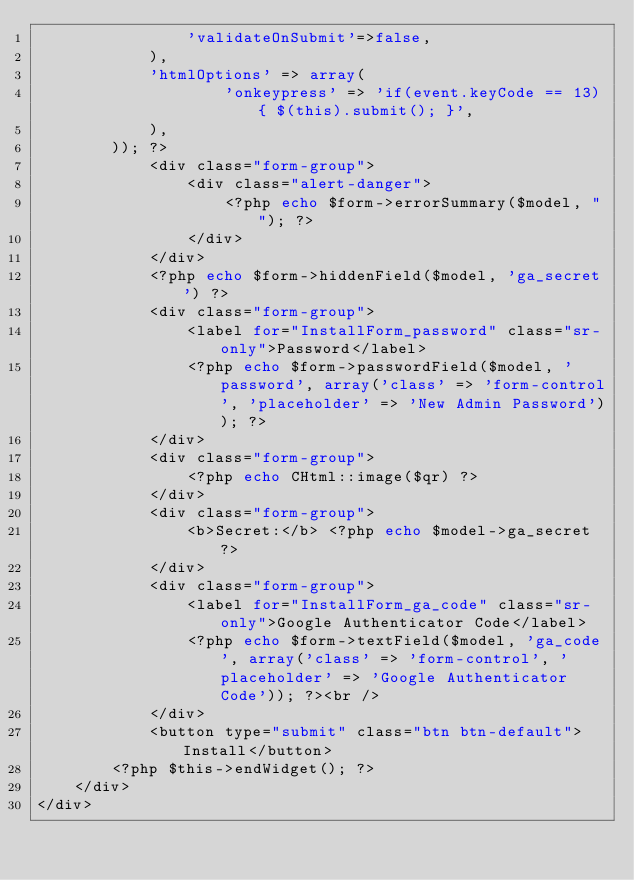Convert code to text. <code><loc_0><loc_0><loc_500><loc_500><_PHP_>				'validateOnSubmit'=>false,
			),
			'htmlOptions' => array(
					'onkeypress' => 'if(event.keyCode == 13){ $(this).submit(); }',
			),
		)); ?>
			<div class="form-group">
				<div class="alert-danger">
					<?php echo $form->errorSummary($model, ""); ?>
				</div>
			</div>
			<?php echo $form->hiddenField($model, 'ga_secret') ?>
			<div class="form-group">
				<label for="InstallForm_password" class="sr-only">Password</label>
				<?php echo $form->passwordField($model, 'password', array('class' => 'form-control', 'placeholder' => 'New Admin Password')); ?>
			</div>
			<div class="form-group">
				<?php echo CHtml::image($qr) ?>
			</div>
			<div class="form-group">
				<b>Secret:</b> <?php echo $model->ga_secret ?>
			</div>
			<div class="form-group">
				<label for="InstallForm_ga_code" class="sr-only">Google Authenticator Code</label>
				<?php echo $form->textField($model, 'ga_code', array('class' => 'form-control', 'placeholder' => 'Google Authenticator Code')); ?><br />
			</div>
			<button type="submit" class="btn btn-default">Install</button>
		<?php $this->endWidget(); ?>
	</div>
</div>
</code> 